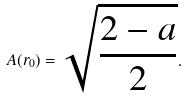<formula> <loc_0><loc_0><loc_500><loc_500>A ( r _ { 0 } ) = \sqrt { \frac { 2 - a } { 2 } } .</formula> 